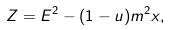<formula> <loc_0><loc_0><loc_500><loc_500>Z = E ^ { 2 } - ( 1 - u ) m ^ { 2 } x ,</formula> 